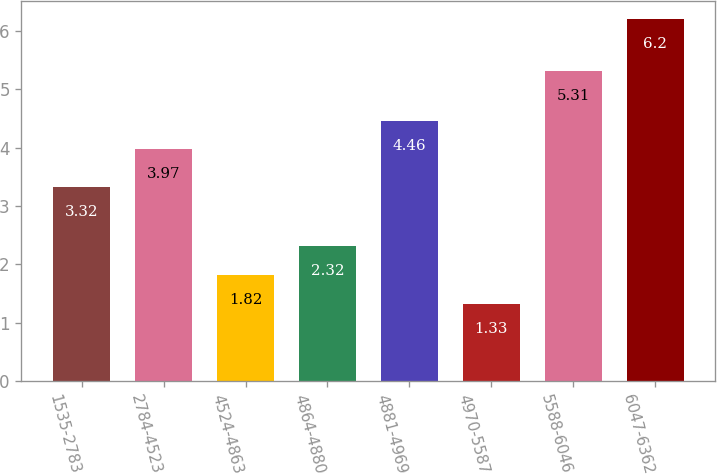Convert chart. <chart><loc_0><loc_0><loc_500><loc_500><bar_chart><fcel>1535-2783<fcel>2784-4523<fcel>4524-4863<fcel>4864-4880<fcel>4881-4969<fcel>4970-5587<fcel>5588-6046<fcel>6047-6362<nl><fcel>3.32<fcel>3.97<fcel>1.82<fcel>2.32<fcel>4.46<fcel>1.33<fcel>5.31<fcel>6.2<nl></chart> 